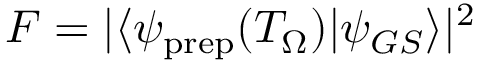<formula> <loc_0><loc_0><loc_500><loc_500>F = | \langle \psi _ { p r e p } ( T _ { \Omega } ) | \psi _ { G S } \rangle | ^ { 2 }</formula> 